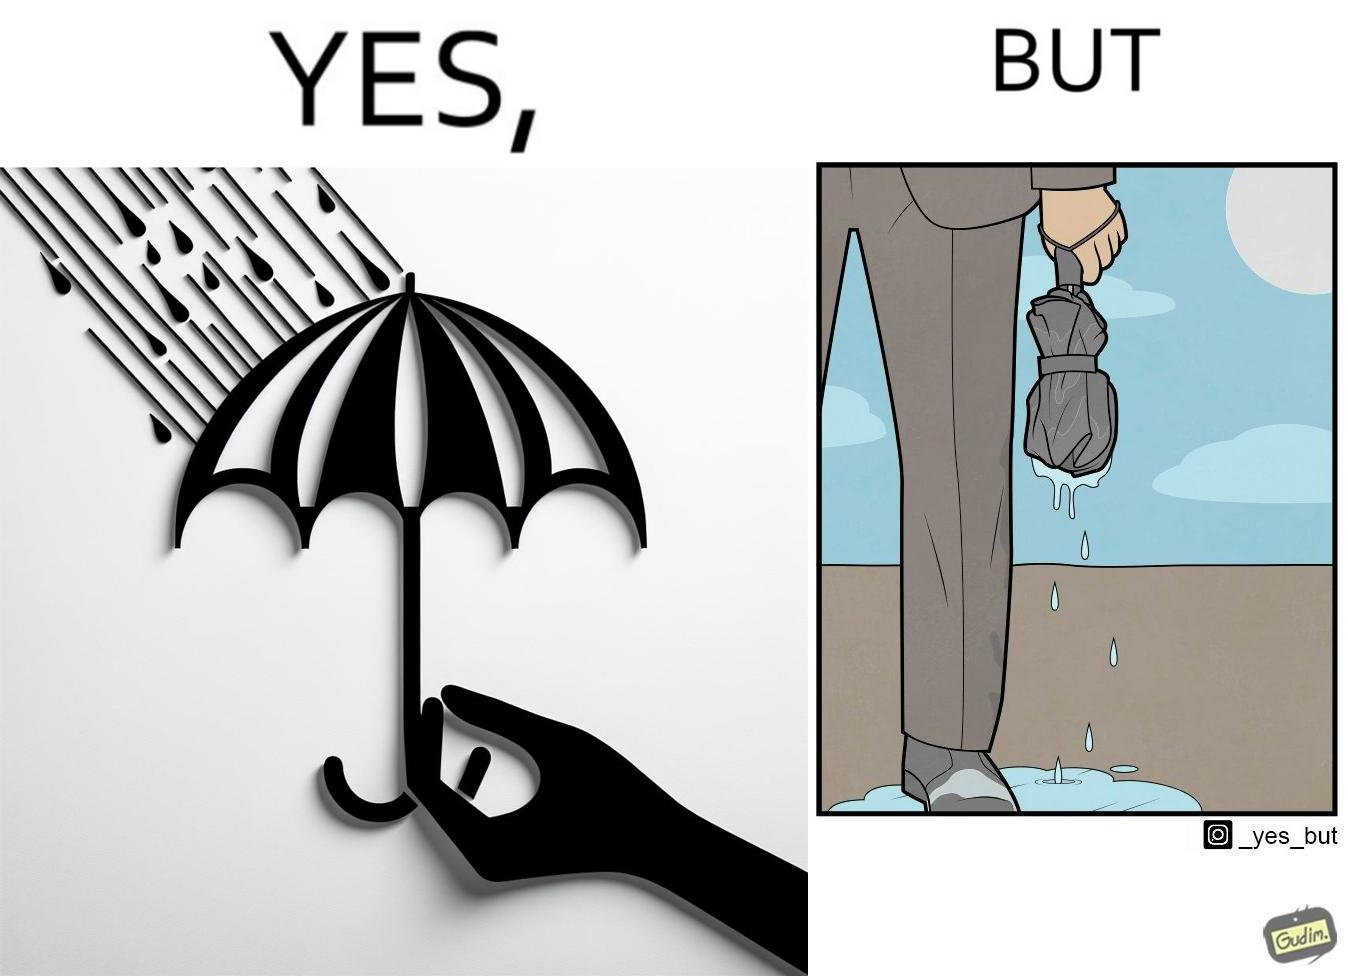Provide a description of this image. The image is funny because while the umbrella helps a person avoid getting wet from rain, when the rain stops and the umbrella is folded, the wet umbrella iteself drips water on the person holding it. 